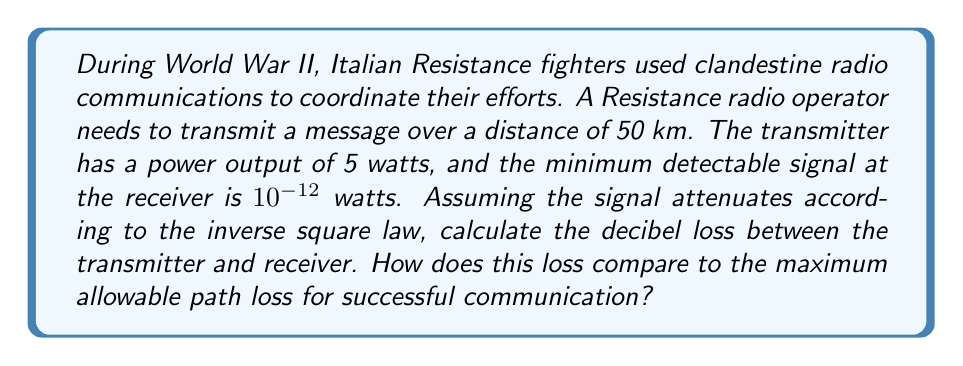Could you help me with this problem? To solve this problem, we'll use logarithms and the decibel formula. Let's break it down step-by-step:

1) First, we need to calculate the ratio of the transmitted power to the received power:
   Transmitted power = 5 watts
   Received power (minimum detectable signal) = $10^{-12}$ watts
   Ratio = $\frac{5}{10^{-12}} = 5 \times 10^{12}$

2) The decibel loss is calculated using the formula:
   $dB = 10 \log_{10}(\frac{P_1}{P_2})$
   Where $P_1$ is the transmitted power and $P_2$ is the received power.

3) Plugging in our values:
   $dB = 10 \log_{10}(5 \times 10^{12})$

4) Using the logarithm property $\log_a(x \times 10^n) = \log_a(x) + n$, we can simplify:
   $dB = 10 (\log_{10}(5) + 12)$

5) Calculate:
   $dB = 10 (0.6990 + 12) = 10 \times 12.6990 = 126.99$ dB

6) To determine the maximum allowable path loss, we need to calculate the free-space path loss using the inverse square law:
   Path loss = $(\frac{4\pi d}{\lambda})^2$
   Where $d$ is the distance and $\lambda$ is the wavelength.

   However, without information about the frequency (and thus wavelength) of the transmission, we can't calculate this precisely.

7) Instead, we can use the fact that the received power is the minimum detectable signal. This means that our calculated 126.99 dB loss is the maximum allowable path loss for successful communication.

Therefore, the actual path loss is equal to the maximum allowable path loss in this scenario, indicating that the communication is at the limit of its range.
Answer: The decibel loss between the transmitter and receiver is 126.99 dB, which is also the maximum allowable path loss for successful communication in this scenario. 